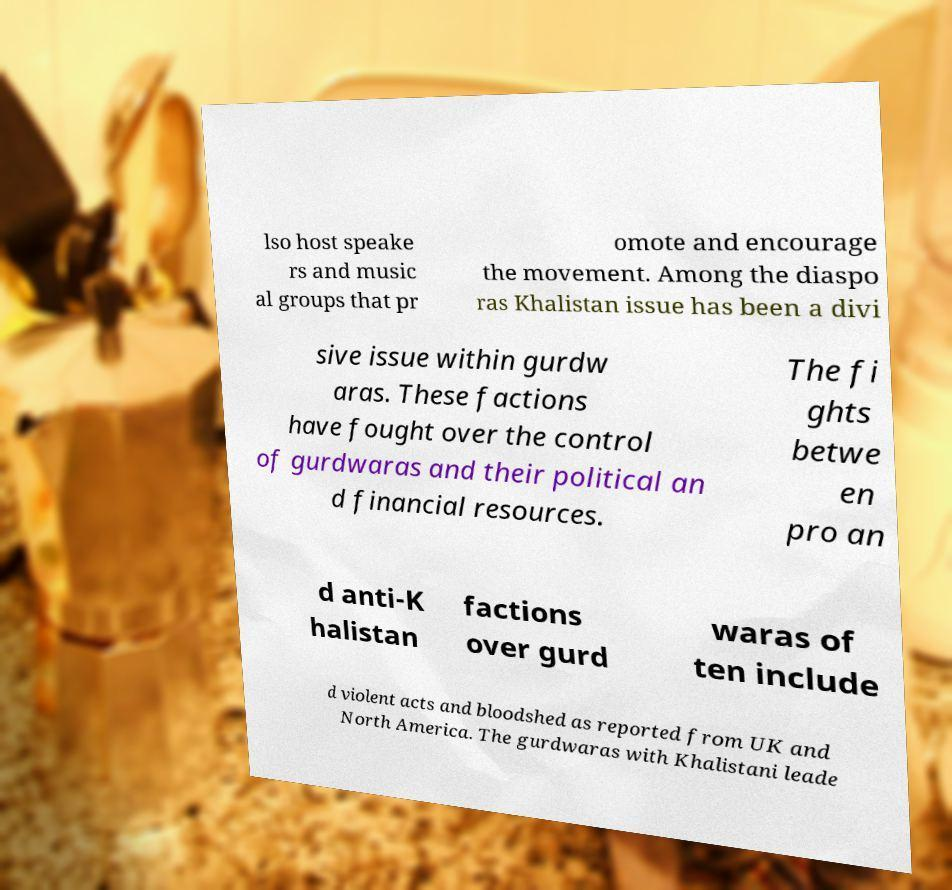What messages or text are displayed in this image? I need them in a readable, typed format. lso host speake rs and music al groups that pr omote and encourage the movement. Among the diaspo ras Khalistan issue has been a divi sive issue within gurdw aras. These factions have fought over the control of gurdwaras and their political an d financial resources. The fi ghts betwe en pro an d anti-K halistan factions over gurd waras of ten include d violent acts and bloodshed as reported from UK and North America. The gurdwaras with Khalistani leade 